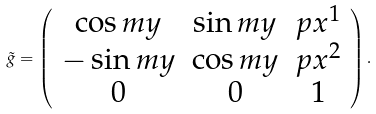<formula> <loc_0><loc_0><loc_500><loc_500>\tilde { g } = \left ( \begin{array} { c c c } \cos { m y } & \sin { m y } & p x ^ { 1 } \\ - \sin { m y } & \cos { m y } & p x ^ { 2 } \\ 0 & 0 & 1 \end{array} \right ) .</formula> 